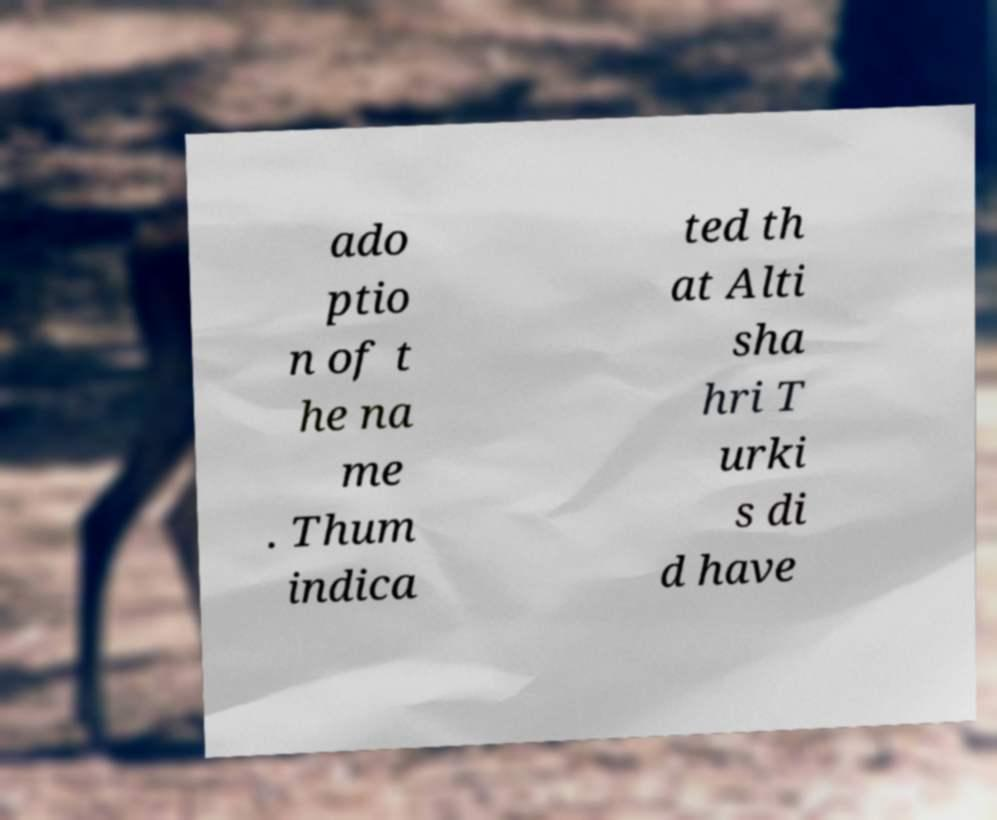There's text embedded in this image that I need extracted. Can you transcribe it verbatim? ado ptio n of t he na me . Thum indica ted th at Alti sha hri T urki s di d have 